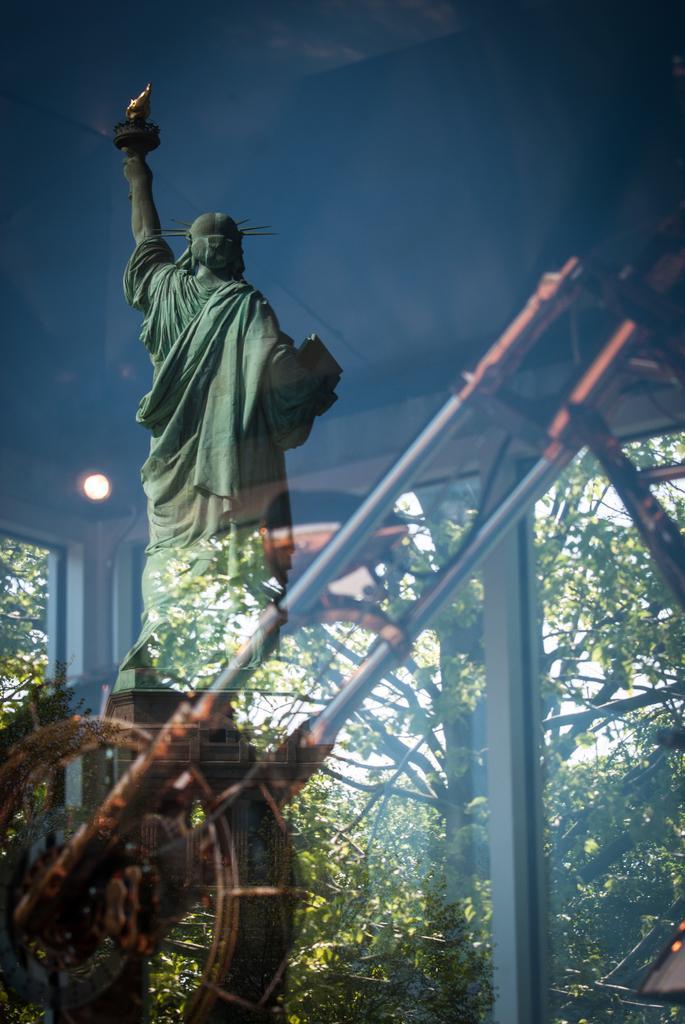Can you describe this image briefly? In the foreground there is a glass. On the glass, I can see the reflection of a statue. Behind the glass there is a metal object. In the background there are some trees. 